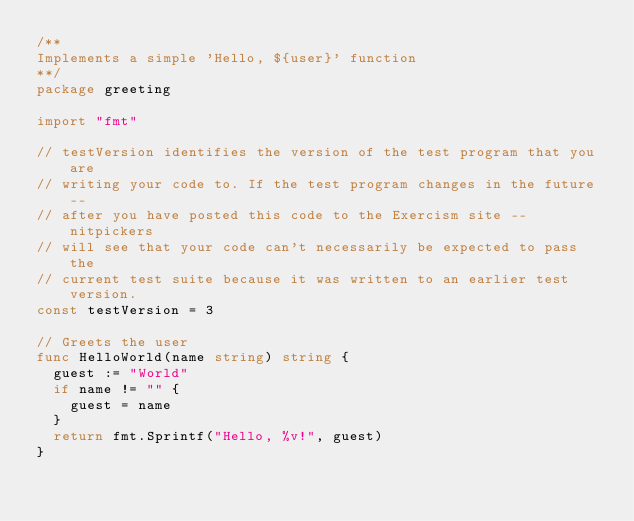Convert code to text. <code><loc_0><loc_0><loc_500><loc_500><_Go_>/**
Implements a simple 'Hello, ${user}' function
**/
package greeting

import "fmt"

// testVersion identifies the version of the test program that you are
// writing your code to. If the test program changes in the future --
// after you have posted this code to the Exercism site -- nitpickers
// will see that your code can't necessarily be expected to pass the
// current test suite because it was written to an earlier test version.
const testVersion = 3

// Greets the user
func HelloWorld(name string) string {
	guest := "World"
	if name != "" {
		guest = name
	}
	return fmt.Sprintf("Hello, %v!", guest)
}
</code> 